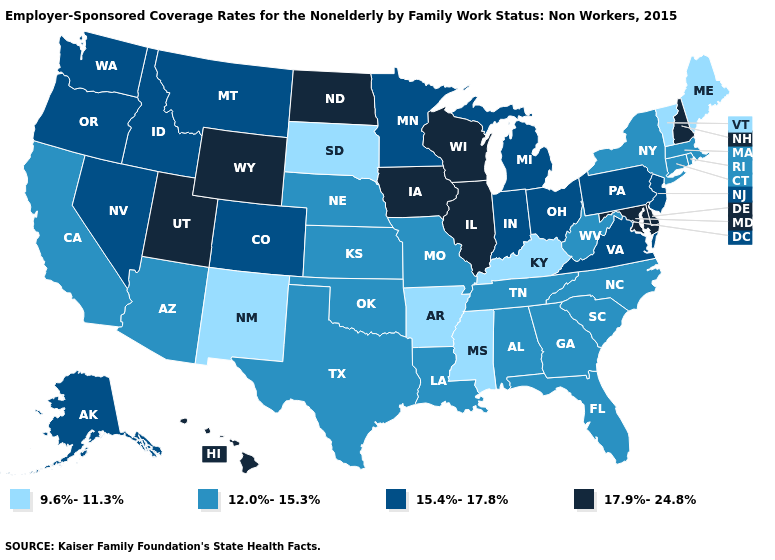Which states have the lowest value in the MidWest?
Answer briefly. South Dakota. Does Connecticut have a higher value than Ohio?
Write a very short answer. No. Among the states that border Nebraska , which have the highest value?
Short answer required. Iowa, Wyoming. What is the highest value in the USA?
Be succinct. 17.9%-24.8%. Name the states that have a value in the range 12.0%-15.3%?
Quick response, please. Alabama, Arizona, California, Connecticut, Florida, Georgia, Kansas, Louisiana, Massachusetts, Missouri, Nebraska, New York, North Carolina, Oklahoma, Rhode Island, South Carolina, Tennessee, Texas, West Virginia. Name the states that have a value in the range 15.4%-17.8%?
Be succinct. Alaska, Colorado, Idaho, Indiana, Michigan, Minnesota, Montana, Nevada, New Jersey, Ohio, Oregon, Pennsylvania, Virginia, Washington. What is the lowest value in the South?
Answer briefly. 9.6%-11.3%. Among the states that border New York , which have the lowest value?
Give a very brief answer. Vermont. What is the value of New Hampshire?
Be succinct. 17.9%-24.8%. What is the value of Missouri?
Be succinct. 12.0%-15.3%. Among the states that border Mississippi , which have the lowest value?
Answer briefly. Arkansas. What is the value of Connecticut?
Write a very short answer. 12.0%-15.3%. Name the states that have a value in the range 12.0%-15.3%?
Keep it brief. Alabama, Arizona, California, Connecticut, Florida, Georgia, Kansas, Louisiana, Massachusetts, Missouri, Nebraska, New York, North Carolina, Oklahoma, Rhode Island, South Carolina, Tennessee, Texas, West Virginia. What is the lowest value in the West?
Give a very brief answer. 9.6%-11.3%. Among the states that border Idaho , which have the lowest value?
Quick response, please. Montana, Nevada, Oregon, Washington. 